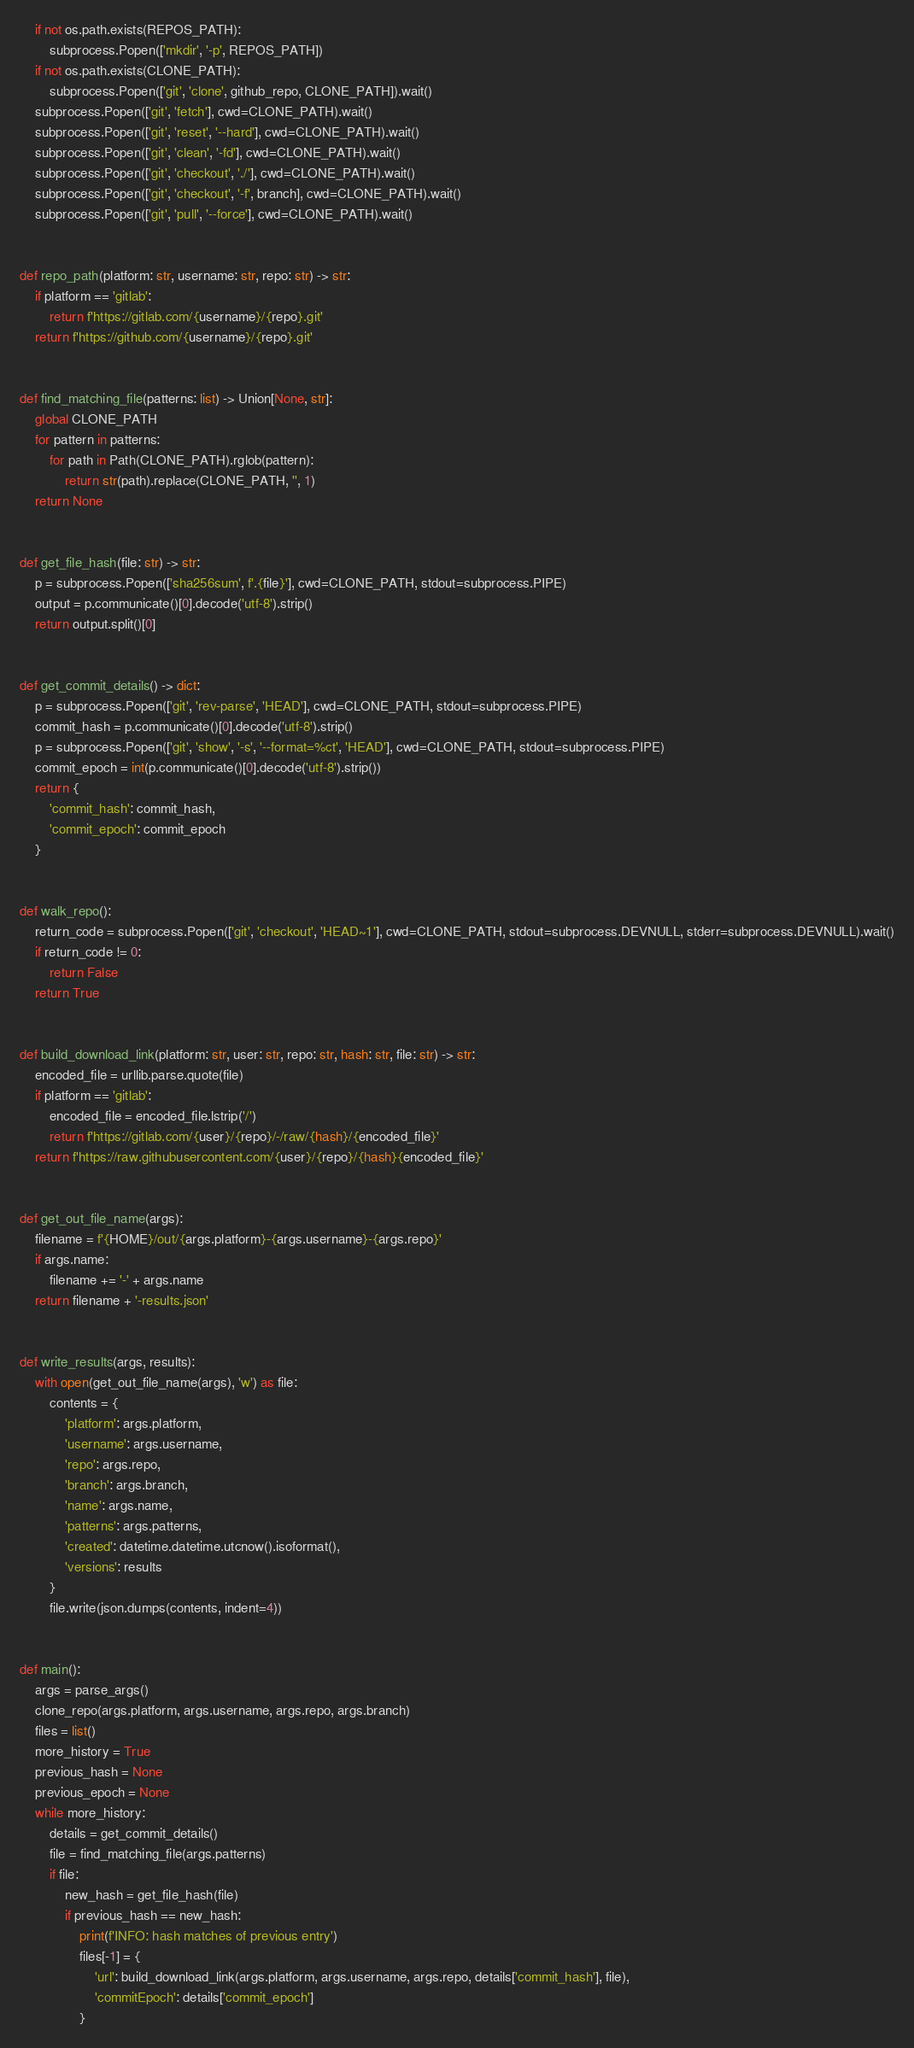<code> <loc_0><loc_0><loc_500><loc_500><_Python_>    if not os.path.exists(REPOS_PATH):
        subprocess.Popen(['mkdir', '-p', REPOS_PATH])
    if not os.path.exists(CLONE_PATH):
        subprocess.Popen(['git', 'clone', github_repo, CLONE_PATH]).wait()
    subprocess.Popen(['git', 'fetch'], cwd=CLONE_PATH).wait()
    subprocess.Popen(['git', 'reset', '--hard'], cwd=CLONE_PATH).wait()
    subprocess.Popen(['git', 'clean', '-fd'], cwd=CLONE_PATH).wait()
    subprocess.Popen(['git', 'checkout', './'], cwd=CLONE_PATH).wait()
    subprocess.Popen(['git', 'checkout', '-f', branch], cwd=CLONE_PATH).wait()
    subprocess.Popen(['git', 'pull', '--force'], cwd=CLONE_PATH).wait()


def repo_path(platform: str, username: str, repo: str) -> str:
    if platform == 'gitlab':
        return f'https://gitlab.com/{username}/{repo}.git'
    return f'https://github.com/{username}/{repo}.git'


def find_matching_file(patterns: list) -> Union[None, str]:
    global CLONE_PATH
    for pattern in patterns:
        for path in Path(CLONE_PATH).rglob(pattern):
            return str(path).replace(CLONE_PATH, '', 1)
    return None


def get_file_hash(file: str) -> str:
    p = subprocess.Popen(['sha256sum', f'.{file}'], cwd=CLONE_PATH, stdout=subprocess.PIPE)
    output = p.communicate()[0].decode('utf-8').strip()
    return output.split()[0]


def get_commit_details() -> dict:
    p = subprocess.Popen(['git', 'rev-parse', 'HEAD'], cwd=CLONE_PATH, stdout=subprocess.PIPE)
    commit_hash = p.communicate()[0].decode('utf-8').strip()
    p = subprocess.Popen(['git', 'show', '-s', '--format=%ct', 'HEAD'], cwd=CLONE_PATH, stdout=subprocess.PIPE)
    commit_epoch = int(p.communicate()[0].decode('utf-8').strip())
    return {
        'commit_hash': commit_hash,
        'commit_epoch': commit_epoch
    }


def walk_repo():
    return_code = subprocess.Popen(['git', 'checkout', 'HEAD~1'], cwd=CLONE_PATH, stdout=subprocess.DEVNULL, stderr=subprocess.DEVNULL).wait()
    if return_code != 0:
        return False
    return True


def build_download_link(platform: str, user: str, repo: str, hash: str, file: str) -> str:
    encoded_file = urllib.parse.quote(file)
    if platform == 'gitlab':
        encoded_file = encoded_file.lstrip('/')
        return f'https://gitlab.com/{user}/{repo}/-/raw/{hash}/{encoded_file}'
    return f'https://raw.githubusercontent.com/{user}/{repo}/{hash}{encoded_file}'


def get_out_file_name(args):
    filename = f'{HOME}/out/{args.platform}-{args.username}-{args.repo}'
    if args.name:
        filename += '-' + args.name
    return filename + '-results.json'


def write_results(args, results):
    with open(get_out_file_name(args), 'w') as file:
        contents = {
            'platform': args.platform,
            'username': args.username,
            'repo': args.repo,
            'branch': args.branch,
            'name': args.name,
            'patterns': args.patterns,
            'created': datetime.datetime.utcnow().isoformat(),
            'versions': results
        }
        file.write(json.dumps(contents, indent=4))


def main():
    args = parse_args()
    clone_repo(args.platform, args.username, args.repo, args.branch)
    files = list()
    more_history = True
    previous_hash = None
    previous_epoch = None
    while more_history:
        details = get_commit_details()
        file = find_matching_file(args.patterns)
        if file:
            new_hash = get_file_hash(file)
            if previous_hash == new_hash:
                print(f'INFO: hash matches of previous entry')
                files[-1] = {
                    'url': build_download_link(args.platform, args.username, args.repo, details['commit_hash'], file),
                    'commitEpoch': details['commit_epoch']
                }</code> 